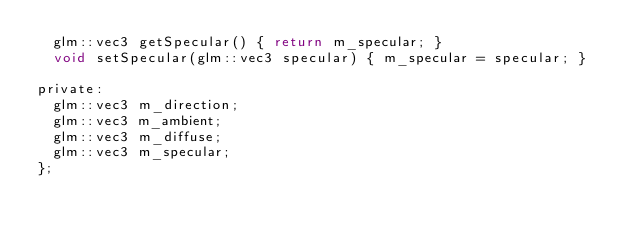<code> <loc_0><loc_0><loc_500><loc_500><_C_>	glm::vec3 getSpecular() { return m_specular; }
	void setSpecular(glm::vec3 specular) { m_specular = specular; }

private:
	glm::vec3 m_direction;
	glm::vec3 m_ambient;
	glm::vec3 m_diffuse;
	glm::vec3 m_specular;
};</code> 